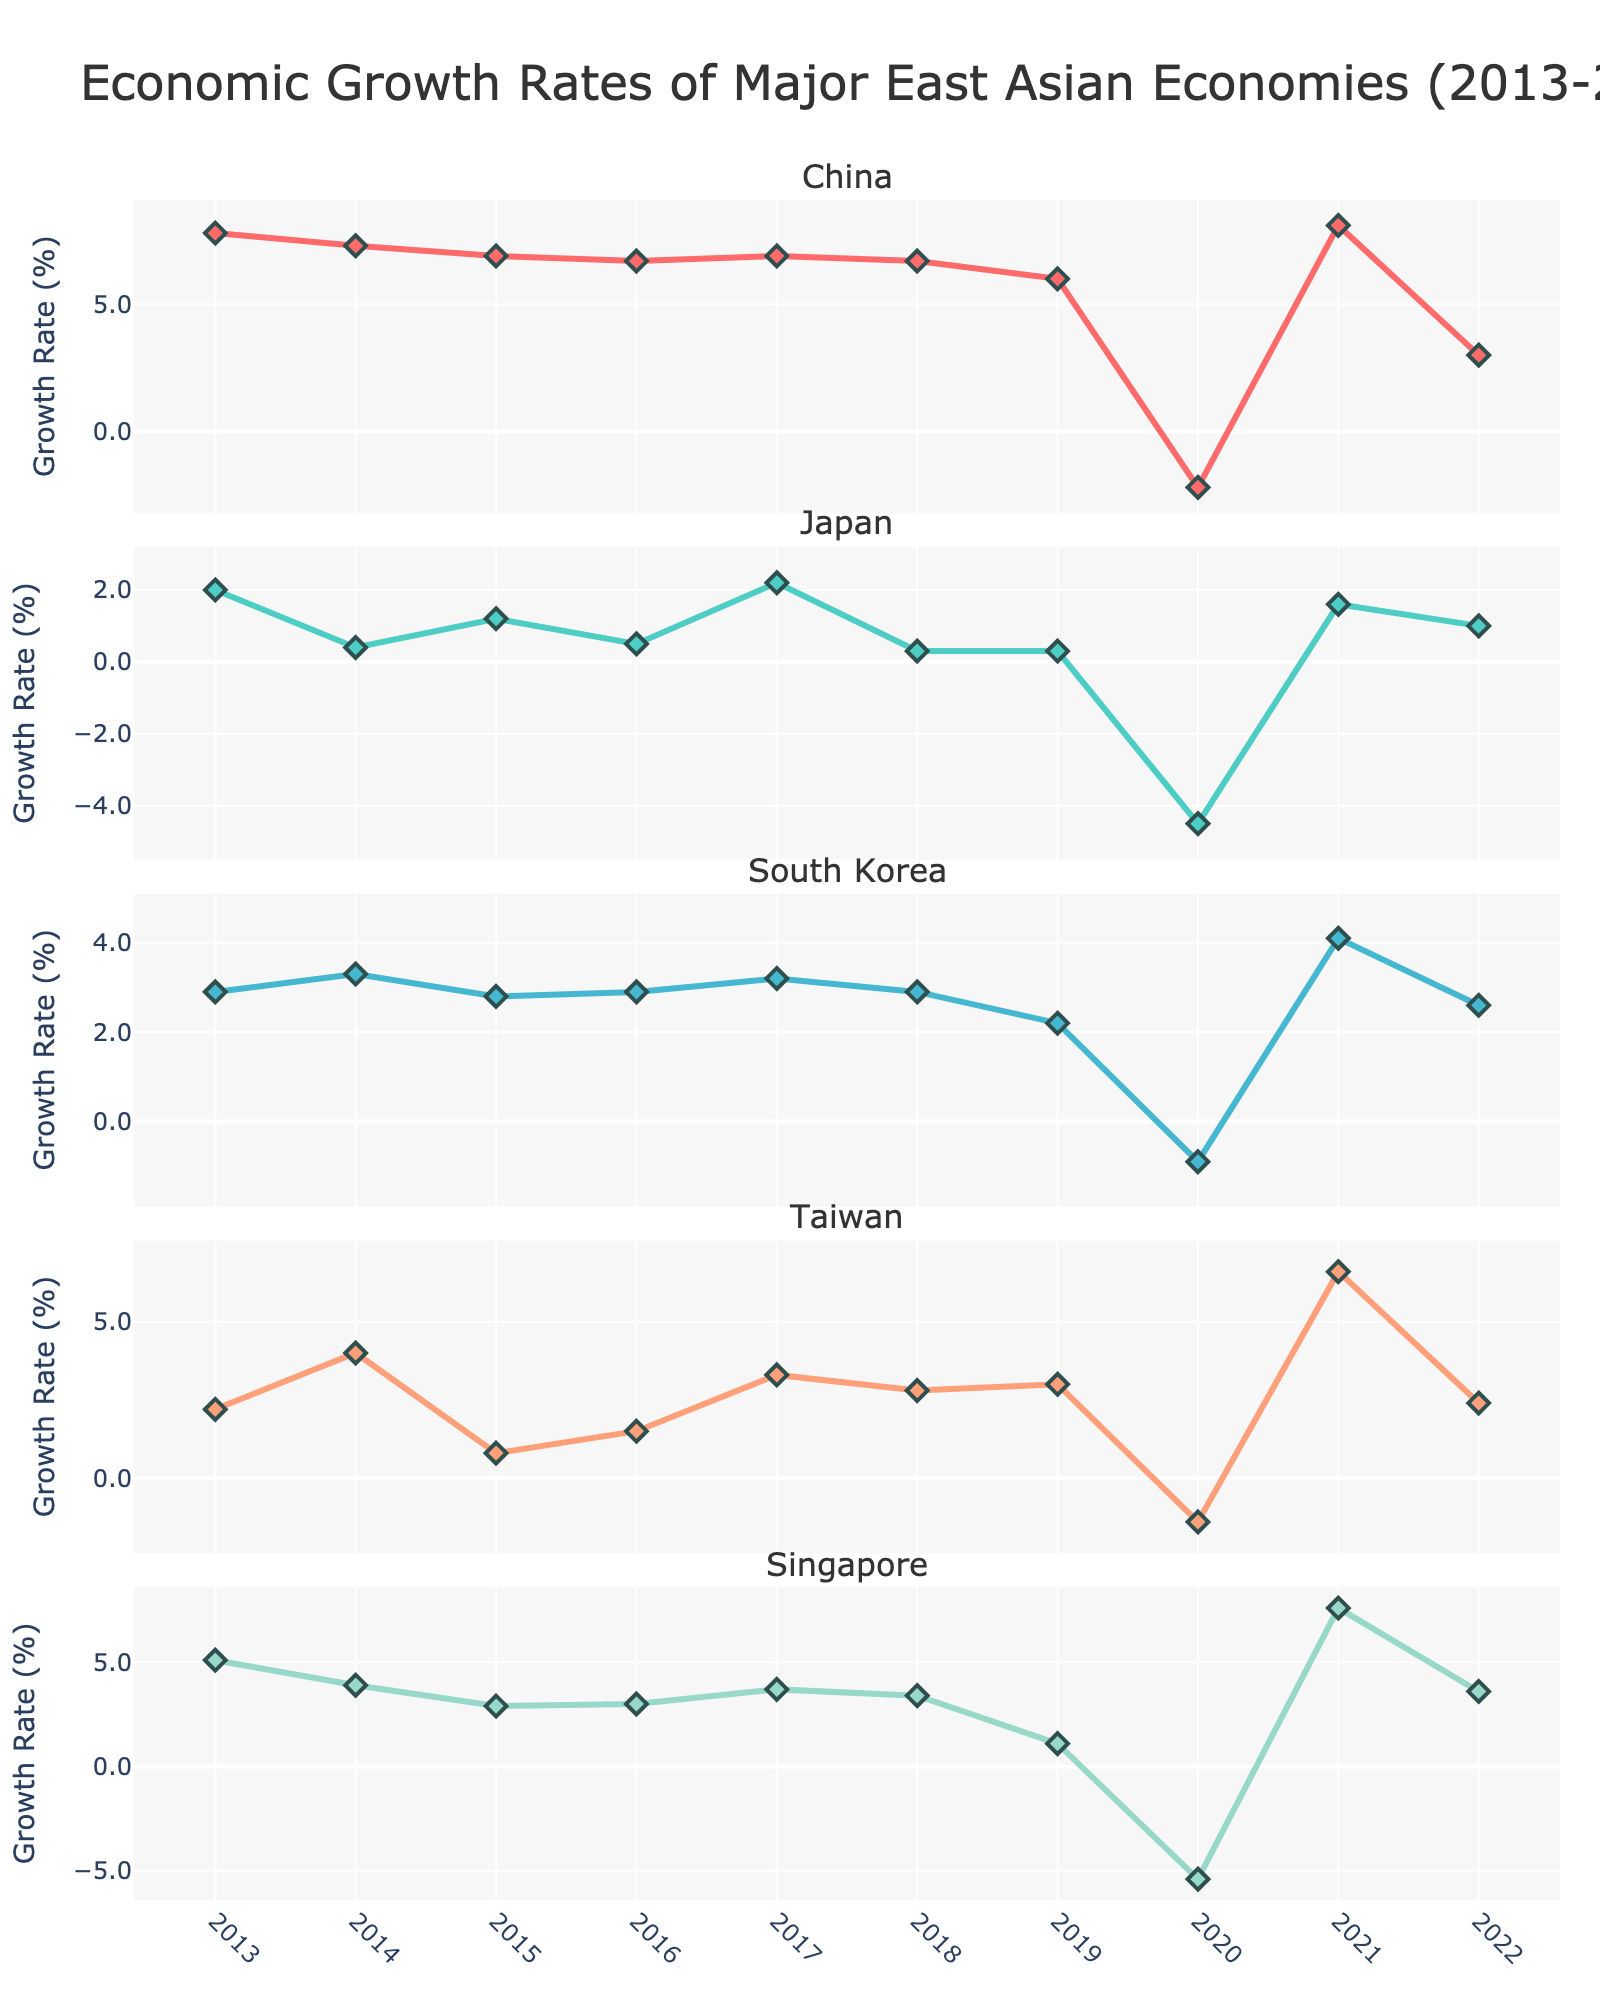What is the title of the plot? The title is located at the top center of the plot, highlighting its main topic.
Answer: Economic Growth Rates of Major East Asian Economies (2013-2022) How many major East Asian economies are being compared? Counting the subplots and their titles helps identify the number of economies.
Answer: 5 Which country had the highest economic growth rate in 2021? Refer to the subplot for each country and identify the peak value for 2021.
Answer: China What is the trend of Japan's economic growth rate from 2013 to 2022? Observe Japan's subplot and trace the line graph from start to end, noting any major upturns or downturns.
Answer: Mostly fluctuates, with significant dips in 2020 and mild growth thereafter Which countries experienced negative growth in 2020? Scan each subplot at the 2020 mark to identify which lines fall below zero.
Answer: China, Japan, South Korea, Taiwan, Singapore What is the average economic growth rate of China from 2013 to 2022? Sum China's growth rates from 2013 to 2022 and divide by the number of years. \( \text{Average} = \frac{(7.8+7.3+6.9+6.7+6.9+6.7+6.0-2.2+8.1+3.0)}{10} \)
Answer: 5.5% Which country had the most volatile economic growth rate over the decade? Look for the country with the most pronounced peaks and troughs by examining the lines' amplitude.
Answer: Japan How did Taiwan's economic growth in 2021 compare to the other years? Find the 2021 data point for Taiwan and compare it to other points in Taiwan's subplot.
Answer: Significantly higher than other years From the data provided, which country had the least variation in their annual economic growth rates? Compare the range (difference between the highest and lowest values) for each country's subplot.
Answer: South Korea 